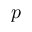<formula> <loc_0><loc_0><loc_500><loc_500>p</formula> 